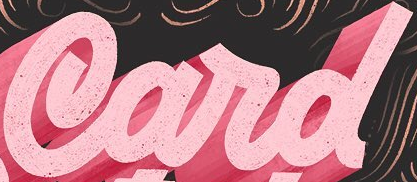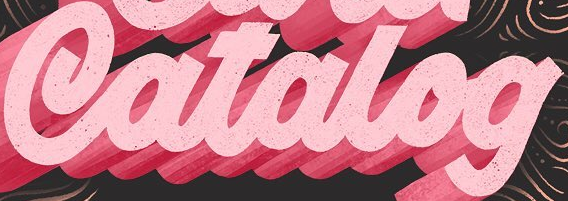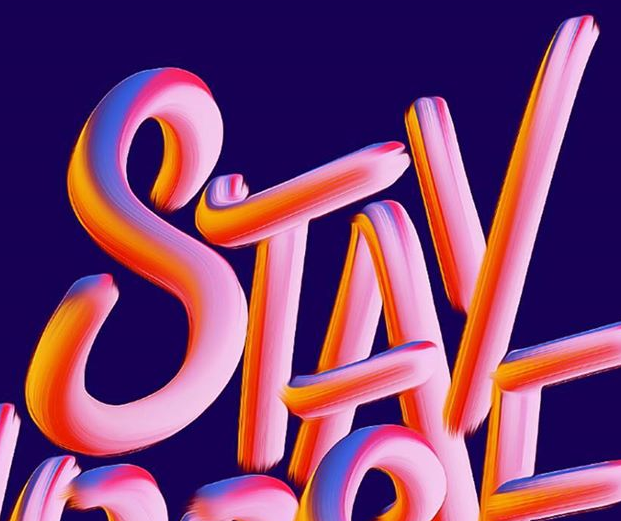What words are shown in these images in order, separated by a semicolon? Card; Catalog; STAY 